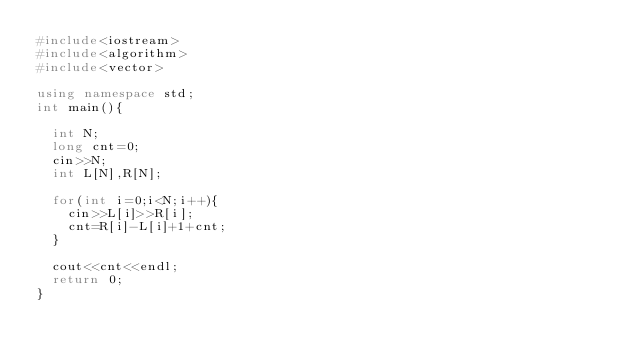<code> <loc_0><loc_0><loc_500><loc_500><_C++_>#include<iostream>
#include<algorithm>
#include<vector>

using namespace std;
int main(){
	
	int N;
	long cnt=0;
	cin>>N;
	int L[N],R[N];
	
	for(int i=0;i<N;i++){
		cin>>L[i]>>R[i];
		cnt=R[i]-L[i]+1+cnt;
	}
	
	cout<<cnt<<endl;
	return 0;
}</code> 